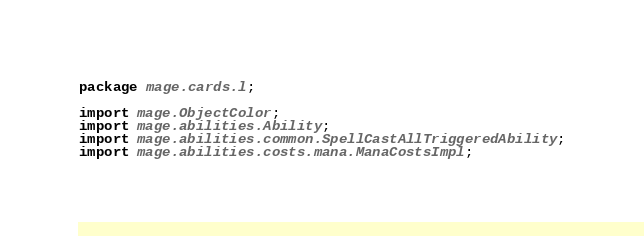<code> <loc_0><loc_0><loc_500><loc_500><_Java_>package mage.cards.l;

import mage.ObjectColor;
import mage.abilities.Ability;
import mage.abilities.common.SpellCastAllTriggeredAbility;
import mage.abilities.costs.mana.ManaCostsImpl;</code> 